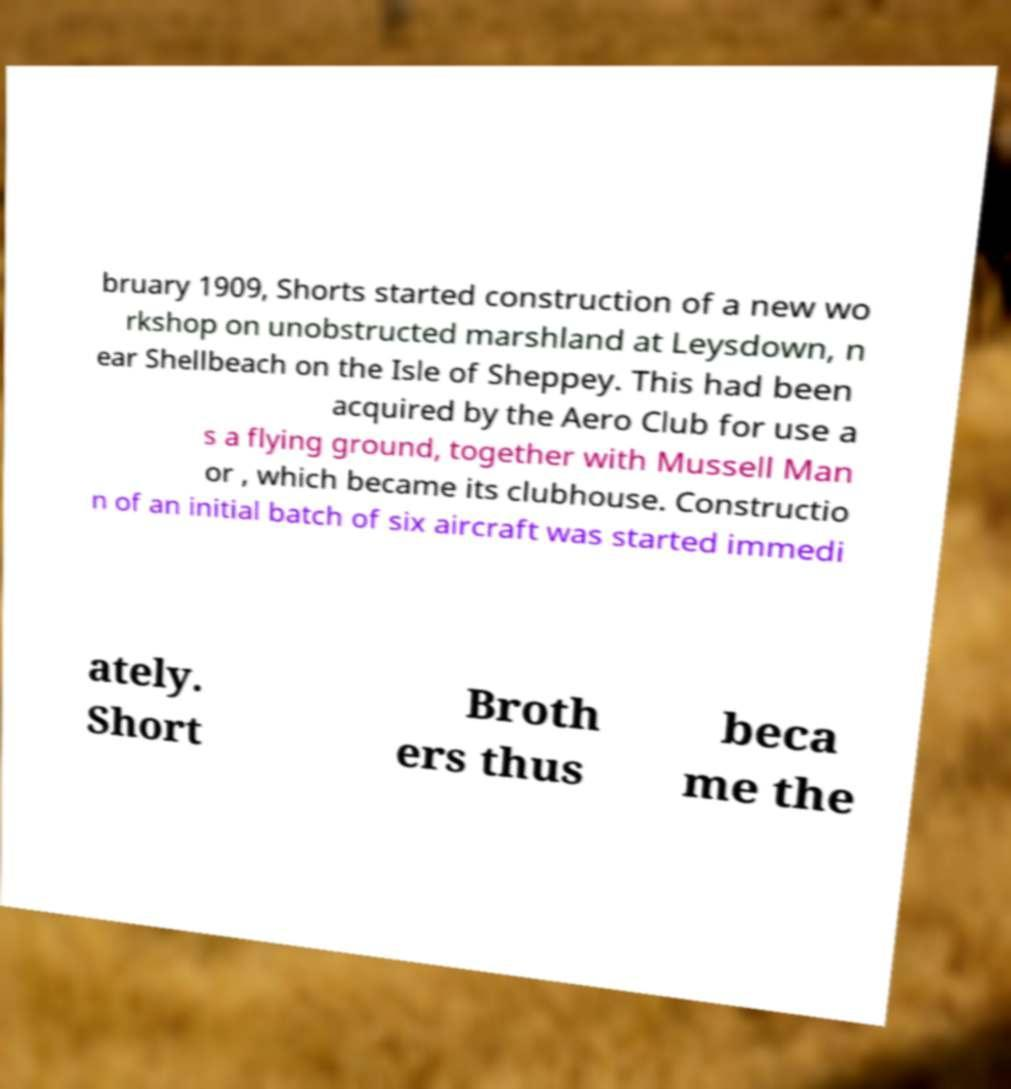Can you read and provide the text displayed in the image?This photo seems to have some interesting text. Can you extract and type it out for me? bruary 1909, Shorts started construction of a new wo rkshop on unobstructed marshland at Leysdown, n ear Shellbeach on the Isle of Sheppey. This had been acquired by the Aero Club for use a s a flying ground, together with Mussell Man or , which became its clubhouse. Constructio n of an initial batch of six aircraft was started immedi ately. Short Broth ers thus beca me the 